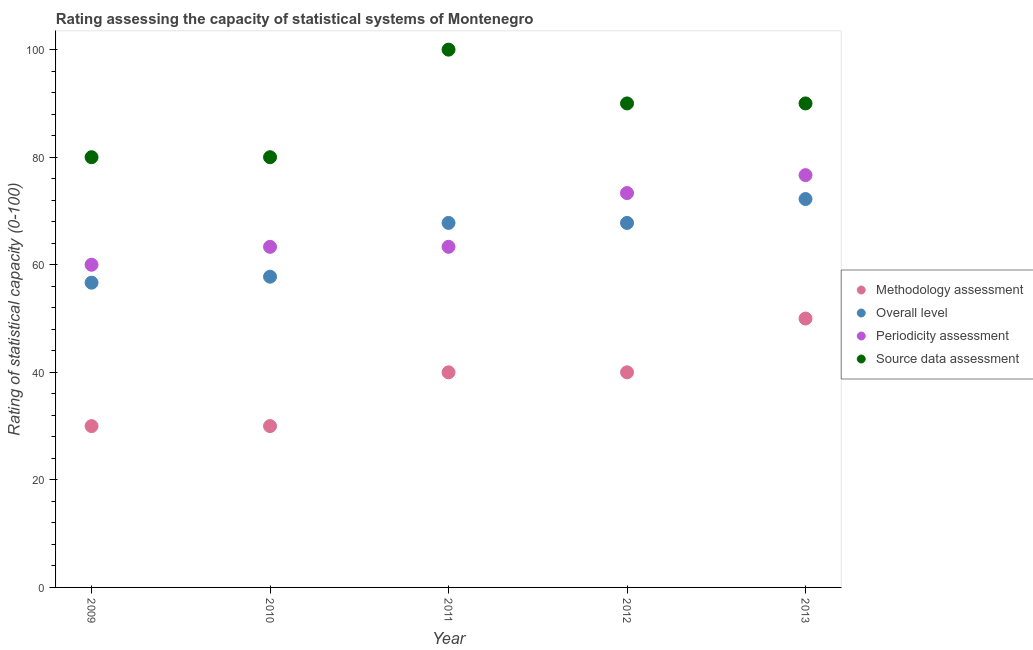How many different coloured dotlines are there?
Keep it short and to the point. 4. Is the number of dotlines equal to the number of legend labels?
Give a very brief answer. Yes. What is the source data assessment rating in 2009?
Offer a very short reply. 80. Across all years, what is the maximum periodicity assessment rating?
Keep it short and to the point. 76.67. Across all years, what is the minimum source data assessment rating?
Provide a succinct answer. 80. What is the total overall level rating in the graph?
Provide a succinct answer. 322.22. What is the difference between the overall level rating in 2009 and that in 2011?
Offer a very short reply. -11.11. What is the difference between the source data assessment rating in 2011 and the methodology assessment rating in 2012?
Your answer should be very brief. 60. What is the average overall level rating per year?
Give a very brief answer. 64.44. In the year 2009, what is the difference between the overall level rating and methodology assessment rating?
Make the answer very short. 26.67. In how many years, is the source data assessment rating greater than 20?
Your answer should be compact. 5. What is the ratio of the source data assessment rating in 2011 to that in 2012?
Your response must be concise. 1.11. What is the difference between the highest and the second highest overall level rating?
Provide a succinct answer. 4.44. What is the difference between the highest and the lowest source data assessment rating?
Offer a terse response. 20. In how many years, is the methodology assessment rating greater than the average methodology assessment rating taken over all years?
Your answer should be very brief. 3. Is it the case that in every year, the sum of the methodology assessment rating and overall level rating is greater than the periodicity assessment rating?
Give a very brief answer. Yes. Is the source data assessment rating strictly greater than the overall level rating over the years?
Provide a succinct answer. Yes. How many dotlines are there?
Your answer should be compact. 4. Are the values on the major ticks of Y-axis written in scientific E-notation?
Your answer should be very brief. No. Does the graph contain any zero values?
Your answer should be very brief. No. Does the graph contain grids?
Make the answer very short. No. How many legend labels are there?
Offer a terse response. 4. What is the title of the graph?
Your answer should be very brief. Rating assessing the capacity of statistical systems of Montenegro. Does "Manufacturing" appear as one of the legend labels in the graph?
Keep it short and to the point. No. What is the label or title of the X-axis?
Your response must be concise. Year. What is the label or title of the Y-axis?
Make the answer very short. Rating of statistical capacity (0-100). What is the Rating of statistical capacity (0-100) in Overall level in 2009?
Keep it short and to the point. 56.67. What is the Rating of statistical capacity (0-100) in Periodicity assessment in 2009?
Provide a short and direct response. 60. What is the Rating of statistical capacity (0-100) in Methodology assessment in 2010?
Ensure brevity in your answer.  30. What is the Rating of statistical capacity (0-100) in Overall level in 2010?
Offer a terse response. 57.78. What is the Rating of statistical capacity (0-100) of Periodicity assessment in 2010?
Offer a very short reply. 63.33. What is the Rating of statistical capacity (0-100) in Source data assessment in 2010?
Ensure brevity in your answer.  80. What is the Rating of statistical capacity (0-100) in Overall level in 2011?
Your answer should be very brief. 67.78. What is the Rating of statistical capacity (0-100) of Periodicity assessment in 2011?
Provide a short and direct response. 63.33. What is the Rating of statistical capacity (0-100) of Source data assessment in 2011?
Your answer should be very brief. 100. What is the Rating of statistical capacity (0-100) in Methodology assessment in 2012?
Your answer should be very brief. 40. What is the Rating of statistical capacity (0-100) of Overall level in 2012?
Offer a terse response. 67.78. What is the Rating of statistical capacity (0-100) of Periodicity assessment in 2012?
Your answer should be very brief. 73.33. What is the Rating of statistical capacity (0-100) of Overall level in 2013?
Offer a very short reply. 72.22. What is the Rating of statistical capacity (0-100) of Periodicity assessment in 2013?
Provide a short and direct response. 76.67. Across all years, what is the maximum Rating of statistical capacity (0-100) of Methodology assessment?
Give a very brief answer. 50. Across all years, what is the maximum Rating of statistical capacity (0-100) of Overall level?
Your response must be concise. 72.22. Across all years, what is the maximum Rating of statistical capacity (0-100) of Periodicity assessment?
Offer a terse response. 76.67. Across all years, what is the minimum Rating of statistical capacity (0-100) of Overall level?
Your answer should be compact. 56.67. What is the total Rating of statistical capacity (0-100) in Methodology assessment in the graph?
Provide a short and direct response. 190. What is the total Rating of statistical capacity (0-100) in Overall level in the graph?
Make the answer very short. 322.22. What is the total Rating of statistical capacity (0-100) of Periodicity assessment in the graph?
Your answer should be compact. 336.67. What is the total Rating of statistical capacity (0-100) in Source data assessment in the graph?
Your response must be concise. 440. What is the difference between the Rating of statistical capacity (0-100) in Overall level in 2009 and that in 2010?
Your response must be concise. -1.11. What is the difference between the Rating of statistical capacity (0-100) of Overall level in 2009 and that in 2011?
Ensure brevity in your answer.  -11.11. What is the difference between the Rating of statistical capacity (0-100) of Periodicity assessment in 2009 and that in 2011?
Provide a short and direct response. -3.33. What is the difference between the Rating of statistical capacity (0-100) of Methodology assessment in 2009 and that in 2012?
Offer a very short reply. -10. What is the difference between the Rating of statistical capacity (0-100) of Overall level in 2009 and that in 2012?
Your answer should be very brief. -11.11. What is the difference between the Rating of statistical capacity (0-100) of Periodicity assessment in 2009 and that in 2012?
Provide a succinct answer. -13.33. What is the difference between the Rating of statistical capacity (0-100) in Overall level in 2009 and that in 2013?
Your response must be concise. -15.56. What is the difference between the Rating of statistical capacity (0-100) of Periodicity assessment in 2009 and that in 2013?
Provide a short and direct response. -16.67. What is the difference between the Rating of statistical capacity (0-100) in Overall level in 2010 and that in 2011?
Give a very brief answer. -10. What is the difference between the Rating of statistical capacity (0-100) in Periodicity assessment in 2010 and that in 2011?
Your answer should be very brief. 0. What is the difference between the Rating of statistical capacity (0-100) in Methodology assessment in 2010 and that in 2012?
Ensure brevity in your answer.  -10. What is the difference between the Rating of statistical capacity (0-100) in Overall level in 2010 and that in 2012?
Provide a succinct answer. -10. What is the difference between the Rating of statistical capacity (0-100) in Methodology assessment in 2010 and that in 2013?
Provide a short and direct response. -20. What is the difference between the Rating of statistical capacity (0-100) in Overall level in 2010 and that in 2013?
Keep it short and to the point. -14.44. What is the difference between the Rating of statistical capacity (0-100) of Periodicity assessment in 2010 and that in 2013?
Offer a very short reply. -13.33. What is the difference between the Rating of statistical capacity (0-100) in Source data assessment in 2010 and that in 2013?
Ensure brevity in your answer.  -10. What is the difference between the Rating of statistical capacity (0-100) of Periodicity assessment in 2011 and that in 2012?
Offer a very short reply. -10. What is the difference between the Rating of statistical capacity (0-100) in Source data assessment in 2011 and that in 2012?
Provide a short and direct response. 10. What is the difference between the Rating of statistical capacity (0-100) in Overall level in 2011 and that in 2013?
Keep it short and to the point. -4.44. What is the difference between the Rating of statistical capacity (0-100) in Periodicity assessment in 2011 and that in 2013?
Provide a succinct answer. -13.33. What is the difference between the Rating of statistical capacity (0-100) in Methodology assessment in 2012 and that in 2013?
Keep it short and to the point. -10. What is the difference between the Rating of statistical capacity (0-100) of Overall level in 2012 and that in 2013?
Provide a short and direct response. -4.44. What is the difference between the Rating of statistical capacity (0-100) in Methodology assessment in 2009 and the Rating of statistical capacity (0-100) in Overall level in 2010?
Give a very brief answer. -27.78. What is the difference between the Rating of statistical capacity (0-100) in Methodology assessment in 2009 and the Rating of statistical capacity (0-100) in Periodicity assessment in 2010?
Make the answer very short. -33.33. What is the difference between the Rating of statistical capacity (0-100) of Overall level in 2009 and the Rating of statistical capacity (0-100) of Periodicity assessment in 2010?
Offer a terse response. -6.67. What is the difference between the Rating of statistical capacity (0-100) in Overall level in 2009 and the Rating of statistical capacity (0-100) in Source data assessment in 2010?
Your response must be concise. -23.33. What is the difference between the Rating of statistical capacity (0-100) of Periodicity assessment in 2009 and the Rating of statistical capacity (0-100) of Source data assessment in 2010?
Provide a succinct answer. -20. What is the difference between the Rating of statistical capacity (0-100) in Methodology assessment in 2009 and the Rating of statistical capacity (0-100) in Overall level in 2011?
Your answer should be very brief. -37.78. What is the difference between the Rating of statistical capacity (0-100) in Methodology assessment in 2009 and the Rating of statistical capacity (0-100) in Periodicity assessment in 2011?
Your answer should be very brief. -33.33. What is the difference between the Rating of statistical capacity (0-100) in Methodology assessment in 2009 and the Rating of statistical capacity (0-100) in Source data assessment in 2011?
Give a very brief answer. -70. What is the difference between the Rating of statistical capacity (0-100) of Overall level in 2009 and the Rating of statistical capacity (0-100) of Periodicity assessment in 2011?
Make the answer very short. -6.67. What is the difference between the Rating of statistical capacity (0-100) in Overall level in 2009 and the Rating of statistical capacity (0-100) in Source data assessment in 2011?
Give a very brief answer. -43.33. What is the difference between the Rating of statistical capacity (0-100) of Periodicity assessment in 2009 and the Rating of statistical capacity (0-100) of Source data assessment in 2011?
Provide a short and direct response. -40. What is the difference between the Rating of statistical capacity (0-100) of Methodology assessment in 2009 and the Rating of statistical capacity (0-100) of Overall level in 2012?
Your answer should be very brief. -37.78. What is the difference between the Rating of statistical capacity (0-100) in Methodology assessment in 2009 and the Rating of statistical capacity (0-100) in Periodicity assessment in 2012?
Make the answer very short. -43.33. What is the difference between the Rating of statistical capacity (0-100) in Methodology assessment in 2009 and the Rating of statistical capacity (0-100) in Source data assessment in 2012?
Make the answer very short. -60. What is the difference between the Rating of statistical capacity (0-100) of Overall level in 2009 and the Rating of statistical capacity (0-100) of Periodicity assessment in 2012?
Ensure brevity in your answer.  -16.67. What is the difference between the Rating of statistical capacity (0-100) of Overall level in 2009 and the Rating of statistical capacity (0-100) of Source data assessment in 2012?
Provide a short and direct response. -33.33. What is the difference between the Rating of statistical capacity (0-100) in Periodicity assessment in 2009 and the Rating of statistical capacity (0-100) in Source data assessment in 2012?
Provide a short and direct response. -30. What is the difference between the Rating of statistical capacity (0-100) in Methodology assessment in 2009 and the Rating of statistical capacity (0-100) in Overall level in 2013?
Ensure brevity in your answer.  -42.22. What is the difference between the Rating of statistical capacity (0-100) in Methodology assessment in 2009 and the Rating of statistical capacity (0-100) in Periodicity assessment in 2013?
Provide a succinct answer. -46.67. What is the difference between the Rating of statistical capacity (0-100) in Methodology assessment in 2009 and the Rating of statistical capacity (0-100) in Source data assessment in 2013?
Your response must be concise. -60. What is the difference between the Rating of statistical capacity (0-100) in Overall level in 2009 and the Rating of statistical capacity (0-100) in Source data assessment in 2013?
Your answer should be compact. -33.33. What is the difference between the Rating of statistical capacity (0-100) in Methodology assessment in 2010 and the Rating of statistical capacity (0-100) in Overall level in 2011?
Offer a very short reply. -37.78. What is the difference between the Rating of statistical capacity (0-100) in Methodology assessment in 2010 and the Rating of statistical capacity (0-100) in Periodicity assessment in 2011?
Offer a terse response. -33.33. What is the difference between the Rating of statistical capacity (0-100) of Methodology assessment in 2010 and the Rating of statistical capacity (0-100) of Source data assessment in 2011?
Make the answer very short. -70. What is the difference between the Rating of statistical capacity (0-100) of Overall level in 2010 and the Rating of statistical capacity (0-100) of Periodicity assessment in 2011?
Keep it short and to the point. -5.56. What is the difference between the Rating of statistical capacity (0-100) in Overall level in 2010 and the Rating of statistical capacity (0-100) in Source data assessment in 2011?
Your answer should be compact. -42.22. What is the difference between the Rating of statistical capacity (0-100) of Periodicity assessment in 2010 and the Rating of statistical capacity (0-100) of Source data assessment in 2011?
Your answer should be compact. -36.67. What is the difference between the Rating of statistical capacity (0-100) in Methodology assessment in 2010 and the Rating of statistical capacity (0-100) in Overall level in 2012?
Your response must be concise. -37.78. What is the difference between the Rating of statistical capacity (0-100) of Methodology assessment in 2010 and the Rating of statistical capacity (0-100) of Periodicity assessment in 2012?
Give a very brief answer. -43.33. What is the difference between the Rating of statistical capacity (0-100) of Methodology assessment in 2010 and the Rating of statistical capacity (0-100) of Source data assessment in 2012?
Provide a short and direct response. -60. What is the difference between the Rating of statistical capacity (0-100) in Overall level in 2010 and the Rating of statistical capacity (0-100) in Periodicity assessment in 2012?
Offer a terse response. -15.56. What is the difference between the Rating of statistical capacity (0-100) of Overall level in 2010 and the Rating of statistical capacity (0-100) of Source data assessment in 2012?
Offer a very short reply. -32.22. What is the difference between the Rating of statistical capacity (0-100) in Periodicity assessment in 2010 and the Rating of statistical capacity (0-100) in Source data assessment in 2012?
Offer a terse response. -26.67. What is the difference between the Rating of statistical capacity (0-100) in Methodology assessment in 2010 and the Rating of statistical capacity (0-100) in Overall level in 2013?
Your answer should be very brief. -42.22. What is the difference between the Rating of statistical capacity (0-100) of Methodology assessment in 2010 and the Rating of statistical capacity (0-100) of Periodicity assessment in 2013?
Keep it short and to the point. -46.67. What is the difference between the Rating of statistical capacity (0-100) of Methodology assessment in 2010 and the Rating of statistical capacity (0-100) of Source data assessment in 2013?
Make the answer very short. -60. What is the difference between the Rating of statistical capacity (0-100) of Overall level in 2010 and the Rating of statistical capacity (0-100) of Periodicity assessment in 2013?
Give a very brief answer. -18.89. What is the difference between the Rating of statistical capacity (0-100) in Overall level in 2010 and the Rating of statistical capacity (0-100) in Source data assessment in 2013?
Provide a short and direct response. -32.22. What is the difference between the Rating of statistical capacity (0-100) of Periodicity assessment in 2010 and the Rating of statistical capacity (0-100) of Source data assessment in 2013?
Your answer should be very brief. -26.67. What is the difference between the Rating of statistical capacity (0-100) of Methodology assessment in 2011 and the Rating of statistical capacity (0-100) of Overall level in 2012?
Your response must be concise. -27.78. What is the difference between the Rating of statistical capacity (0-100) in Methodology assessment in 2011 and the Rating of statistical capacity (0-100) in Periodicity assessment in 2012?
Your response must be concise. -33.33. What is the difference between the Rating of statistical capacity (0-100) in Overall level in 2011 and the Rating of statistical capacity (0-100) in Periodicity assessment in 2012?
Keep it short and to the point. -5.56. What is the difference between the Rating of statistical capacity (0-100) in Overall level in 2011 and the Rating of statistical capacity (0-100) in Source data assessment in 2012?
Provide a short and direct response. -22.22. What is the difference between the Rating of statistical capacity (0-100) of Periodicity assessment in 2011 and the Rating of statistical capacity (0-100) of Source data assessment in 2012?
Provide a succinct answer. -26.67. What is the difference between the Rating of statistical capacity (0-100) in Methodology assessment in 2011 and the Rating of statistical capacity (0-100) in Overall level in 2013?
Provide a succinct answer. -32.22. What is the difference between the Rating of statistical capacity (0-100) in Methodology assessment in 2011 and the Rating of statistical capacity (0-100) in Periodicity assessment in 2013?
Offer a terse response. -36.67. What is the difference between the Rating of statistical capacity (0-100) in Overall level in 2011 and the Rating of statistical capacity (0-100) in Periodicity assessment in 2013?
Give a very brief answer. -8.89. What is the difference between the Rating of statistical capacity (0-100) of Overall level in 2011 and the Rating of statistical capacity (0-100) of Source data assessment in 2013?
Your answer should be very brief. -22.22. What is the difference between the Rating of statistical capacity (0-100) in Periodicity assessment in 2011 and the Rating of statistical capacity (0-100) in Source data assessment in 2013?
Make the answer very short. -26.67. What is the difference between the Rating of statistical capacity (0-100) of Methodology assessment in 2012 and the Rating of statistical capacity (0-100) of Overall level in 2013?
Ensure brevity in your answer.  -32.22. What is the difference between the Rating of statistical capacity (0-100) of Methodology assessment in 2012 and the Rating of statistical capacity (0-100) of Periodicity assessment in 2013?
Your response must be concise. -36.67. What is the difference between the Rating of statistical capacity (0-100) in Overall level in 2012 and the Rating of statistical capacity (0-100) in Periodicity assessment in 2013?
Ensure brevity in your answer.  -8.89. What is the difference between the Rating of statistical capacity (0-100) in Overall level in 2012 and the Rating of statistical capacity (0-100) in Source data assessment in 2013?
Offer a very short reply. -22.22. What is the difference between the Rating of statistical capacity (0-100) of Periodicity assessment in 2012 and the Rating of statistical capacity (0-100) of Source data assessment in 2013?
Your answer should be compact. -16.67. What is the average Rating of statistical capacity (0-100) in Methodology assessment per year?
Make the answer very short. 38. What is the average Rating of statistical capacity (0-100) of Overall level per year?
Ensure brevity in your answer.  64.44. What is the average Rating of statistical capacity (0-100) of Periodicity assessment per year?
Your response must be concise. 67.33. What is the average Rating of statistical capacity (0-100) in Source data assessment per year?
Offer a very short reply. 88. In the year 2009, what is the difference between the Rating of statistical capacity (0-100) of Methodology assessment and Rating of statistical capacity (0-100) of Overall level?
Your response must be concise. -26.67. In the year 2009, what is the difference between the Rating of statistical capacity (0-100) of Overall level and Rating of statistical capacity (0-100) of Periodicity assessment?
Keep it short and to the point. -3.33. In the year 2009, what is the difference between the Rating of statistical capacity (0-100) of Overall level and Rating of statistical capacity (0-100) of Source data assessment?
Your answer should be very brief. -23.33. In the year 2009, what is the difference between the Rating of statistical capacity (0-100) of Periodicity assessment and Rating of statistical capacity (0-100) of Source data assessment?
Provide a succinct answer. -20. In the year 2010, what is the difference between the Rating of statistical capacity (0-100) of Methodology assessment and Rating of statistical capacity (0-100) of Overall level?
Your response must be concise. -27.78. In the year 2010, what is the difference between the Rating of statistical capacity (0-100) in Methodology assessment and Rating of statistical capacity (0-100) in Periodicity assessment?
Your answer should be very brief. -33.33. In the year 2010, what is the difference between the Rating of statistical capacity (0-100) of Overall level and Rating of statistical capacity (0-100) of Periodicity assessment?
Offer a very short reply. -5.56. In the year 2010, what is the difference between the Rating of statistical capacity (0-100) in Overall level and Rating of statistical capacity (0-100) in Source data assessment?
Ensure brevity in your answer.  -22.22. In the year 2010, what is the difference between the Rating of statistical capacity (0-100) in Periodicity assessment and Rating of statistical capacity (0-100) in Source data assessment?
Keep it short and to the point. -16.67. In the year 2011, what is the difference between the Rating of statistical capacity (0-100) of Methodology assessment and Rating of statistical capacity (0-100) of Overall level?
Make the answer very short. -27.78. In the year 2011, what is the difference between the Rating of statistical capacity (0-100) in Methodology assessment and Rating of statistical capacity (0-100) in Periodicity assessment?
Provide a succinct answer. -23.33. In the year 2011, what is the difference between the Rating of statistical capacity (0-100) of Methodology assessment and Rating of statistical capacity (0-100) of Source data assessment?
Give a very brief answer. -60. In the year 2011, what is the difference between the Rating of statistical capacity (0-100) of Overall level and Rating of statistical capacity (0-100) of Periodicity assessment?
Your answer should be very brief. 4.44. In the year 2011, what is the difference between the Rating of statistical capacity (0-100) of Overall level and Rating of statistical capacity (0-100) of Source data assessment?
Offer a very short reply. -32.22. In the year 2011, what is the difference between the Rating of statistical capacity (0-100) of Periodicity assessment and Rating of statistical capacity (0-100) of Source data assessment?
Provide a succinct answer. -36.67. In the year 2012, what is the difference between the Rating of statistical capacity (0-100) in Methodology assessment and Rating of statistical capacity (0-100) in Overall level?
Ensure brevity in your answer.  -27.78. In the year 2012, what is the difference between the Rating of statistical capacity (0-100) in Methodology assessment and Rating of statistical capacity (0-100) in Periodicity assessment?
Your answer should be compact. -33.33. In the year 2012, what is the difference between the Rating of statistical capacity (0-100) of Overall level and Rating of statistical capacity (0-100) of Periodicity assessment?
Offer a very short reply. -5.56. In the year 2012, what is the difference between the Rating of statistical capacity (0-100) of Overall level and Rating of statistical capacity (0-100) of Source data assessment?
Give a very brief answer. -22.22. In the year 2012, what is the difference between the Rating of statistical capacity (0-100) in Periodicity assessment and Rating of statistical capacity (0-100) in Source data assessment?
Your response must be concise. -16.67. In the year 2013, what is the difference between the Rating of statistical capacity (0-100) in Methodology assessment and Rating of statistical capacity (0-100) in Overall level?
Offer a terse response. -22.22. In the year 2013, what is the difference between the Rating of statistical capacity (0-100) of Methodology assessment and Rating of statistical capacity (0-100) of Periodicity assessment?
Keep it short and to the point. -26.67. In the year 2013, what is the difference between the Rating of statistical capacity (0-100) of Methodology assessment and Rating of statistical capacity (0-100) of Source data assessment?
Your answer should be very brief. -40. In the year 2013, what is the difference between the Rating of statistical capacity (0-100) in Overall level and Rating of statistical capacity (0-100) in Periodicity assessment?
Provide a short and direct response. -4.44. In the year 2013, what is the difference between the Rating of statistical capacity (0-100) in Overall level and Rating of statistical capacity (0-100) in Source data assessment?
Give a very brief answer. -17.78. In the year 2013, what is the difference between the Rating of statistical capacity (0-100) in Periodicity assessment and Rating of statistical capacity (0-100) in Source data assessment?
Your answer should be very brief. -13.33. What is the ratio of the Rating of statistical capacity (0-100) of Methodology assessment in 2009 to that in 2010?
Your answer should be compact. 1. What is the ratio of the Rating of statistical capacity (0-100) in Overall level in 2009 to that in 2010?
Keep it short and to the point. 0.98. What is the ratio of the Rating of statistical capacity (0-100) in Periodicity assessment in 2009 to that in 2010?
Keep it short and to the point. 0.95. What is the ratio of the Rating of statistical capacity (0-100) of Methodology assessment in 2009 to that in 2011?
Provide a succinct answer. 0.75. What is the ratio of the Rating of statistical capacity (0-100) in Overall level in 2009 to that in 2011?
Offer a very short reply. 0.84. What is the ratio of the Rating of statistical capacity (0-100) of Periodicity assessment in 2009 to that in 2011?
Make the answer very short. 0.95. What is the ratio of the Rating of statistical capacity (0-100) of Methodology assessment in 2009 to that in 2012?
Offer a terse response. 0.75. What is the ratio of the Rating of statistical capacity (0-100) of Overall level in 2009 to that in 2012?
Provide a succinct answer. 0.84. What is the ratio of the Rating of statistical capacity (0-100) of Periodicity assessment in 2009 to that in 2012?
Give a very brief answer. 0.82. What is the ratio of the Rating of statistical capacity (0-100) of Overall level in 2009 to that in 2013?
Your response must be concise. 0.78. What is the ratio of the Rating of statistical capacity (0-100) in Periodicity assessment in 2009 to that in 2013?
Your answer should be compact. 0.78. What is the ratio of the Rating of statistical capacity (0-100) of Methodology assessment in 2010 to that in 2011?
Your answer should be very brief. 0.75. What is the ratio of the Rating of statistical capacity (0-100) in Overall level in 2010 to that in 2011?
Provide a succinct answer. 0.85. What is the ratio of the Rating of statistical capacity (0-100) in Periodicity assessment in 2010 to that in 2011?
Your response must be concise. 1. What is the ratio of the Rating of statistical capacity (0-100) of Source data assessment in 2010 to that in 2011?
Make the answer very short. 0.8. What is the ratio of the Rating of statistical capacity (0-100) of Methodology assessment in 2010 to that in 2012?
Provide a succinct answer. 0.75. What is the ratio of the Rating of statistical capacity (0-100) in Overall level in 2010 to that in 2012?
Ensure brevity in your answer.  0.85. What is the ratio of the Rating of statistical capacity (0-100) of Periodicity assessment in 2010 to that in 2012?
Give a very brief answer. 0.86. What is the ratio of the Rating of statistical capacity (0-100) of Source data assessment in 2010 to that in 2012?
Offer a terse response. 0.89. What is the ratio of the Rating of statistical capacity (0-100) of Methodology assessment in 2010 to that in 2013?
Offer a very short reply. 0.6. What is the ratio of the Rating of statistical capacity (0-100) in Periodicity assessment in 2010 to that in 2013?
Your answer should be compact. 0.83. What is the ratio of the Rating of statistical capacity (0-100) of Periodicity assessment in 2011 to that in 2012?
Make the answer very short. 0.86. What is the ratio of the Rating of statistical capacity (0-100) of Overall level in 2011 to that in 2013?
Your answer should be very brief. 0.94. What is the ratio of the Rating of statistical capacity (0-100) of Periodicity assessment in 2011 to that in 2013?
Ensure brevity in your answer.  0.83. What is the ratio of the Rating of statistical capacity (0-100) of Source data assessment in 2011 to that in 2013?
Your answer should be compact. 1.11. What is the ratio of the Rating of statistical capacity (0-100) in Overall level in 2012 to that in 2013?
Make the answer very short. 0.94. What is the ratio of the Rating of statistical capacity (0-100) in Periodicity assessment in 2012 to that in 2013?
Provide a short and direct response. 0.96. What is the difference between the highest and the second highest Rating of statistical capacity (0-100) in Overall level?
Provide a short and direct response. 4.44. What is the difference between the highest and the second highest Rating of statistical capacity (0-100) of Source data assessment?
Provide a short and direct response. 10. What is the difference between the highest and the lowest Rating of statistical capacity (0-100) in Methodology assessment?
Ensure brevity in your answer.  20. What is the difference between the highest and the lowest Rating of statistical capacity (0-100) in Overall level?
Ensure brevity in your answer.  15.56. What is the difference between the highest and the lowest Rating of statistical capacity (0-100) in Periodicity assessment?
Ensure brevity in your answer.  16.67. 